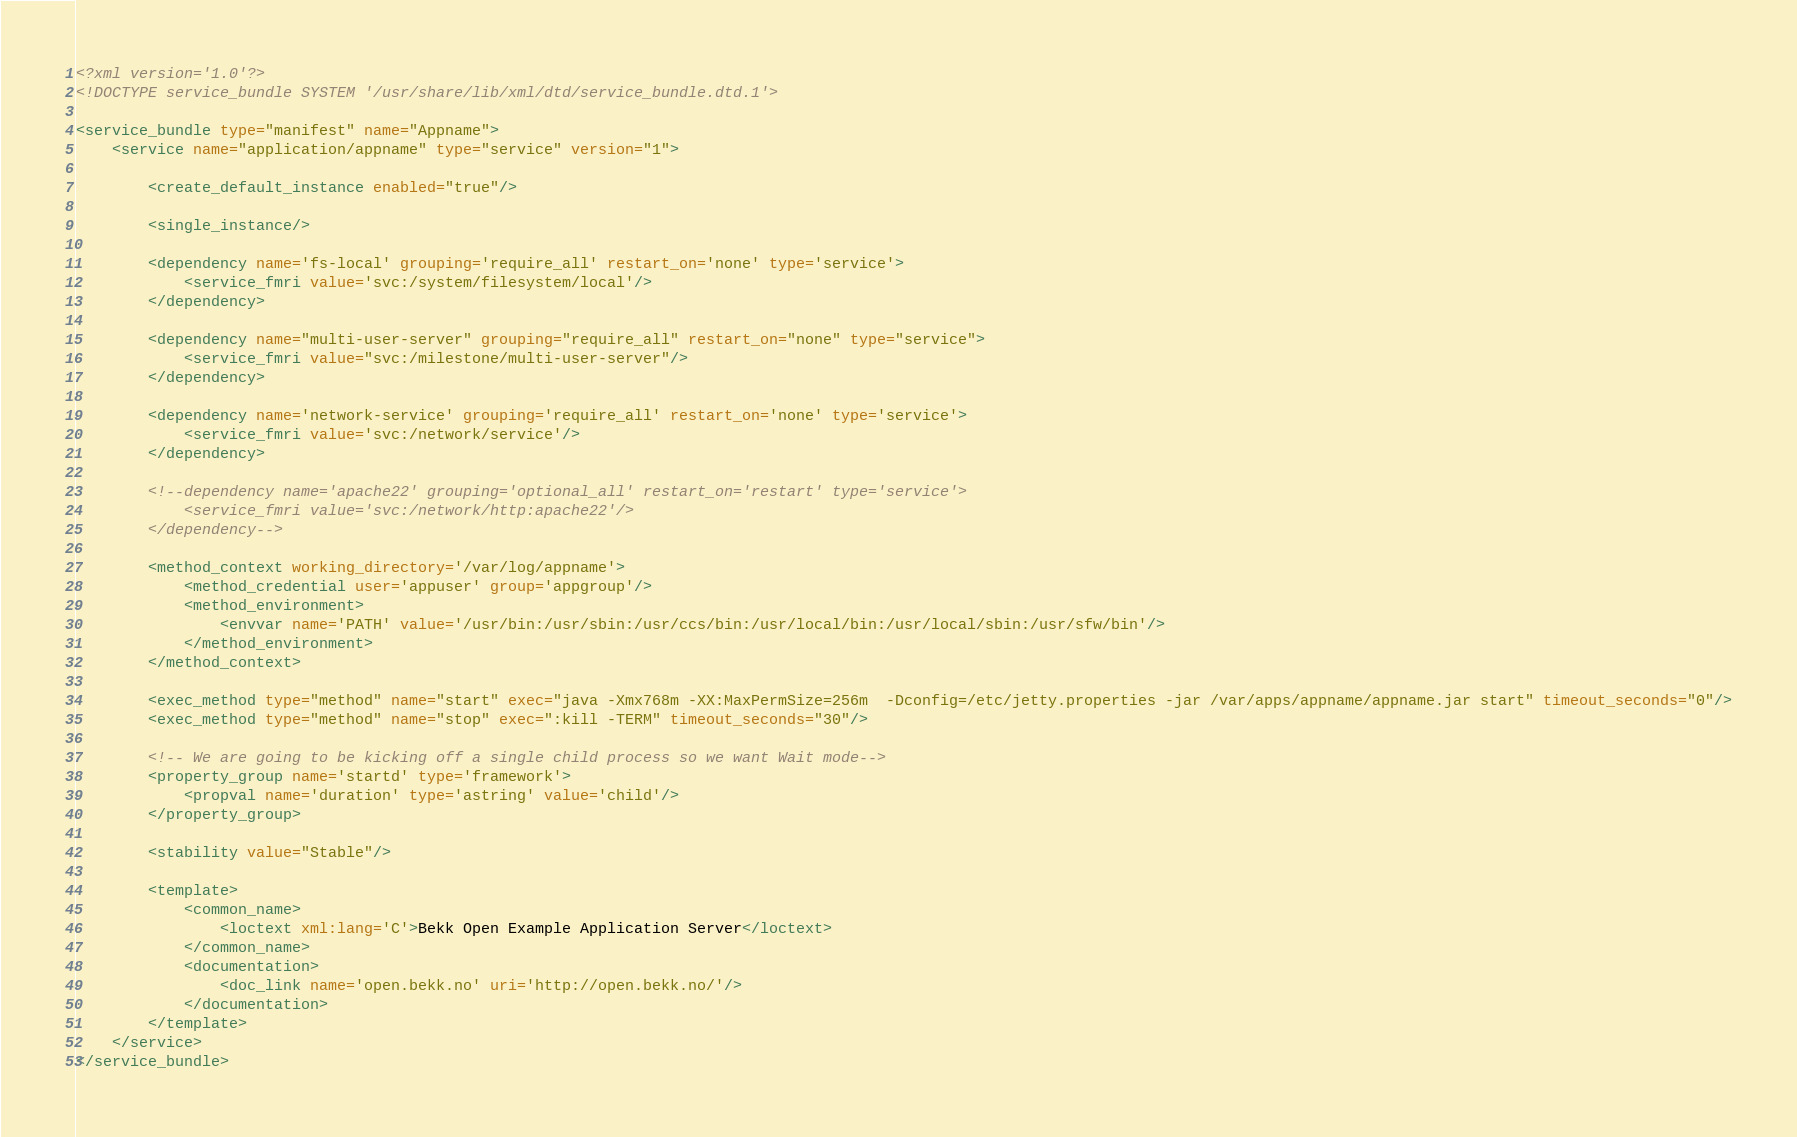Convert code to text. <code><loc_0><loc_0><loc_500><loc_500><_XML_><?xml version='1.0'?>
<!DOCTYPE service_bundle SYSTEM '/usr/share/lib/xml/dtd/service_bundle.dtd.1'>

<service_bundle type="manifest" name="Appname">
    <service name="application/appname" type="service" version="1">

        <create_default_instance enabled="true"/>

        <single_instance/>

        <dependency name='fs-local' grouping='require_all' restart_on='none' type='service'>
            <service_fmri value='svc:/system/filesystem/local'/>
        </dependency>

        <dependency name="multi-user-server" grouping="require_all" restart_on="none" type="service">
            <service_fmri value="svc:/milestone/multi-user-server"/>
        </dependency>

        <dependency name='network-service' grouping='require_all' restart_on='none' type='service'>
            <service_fmri value='svc:/network/service'/>
        </dependency>

        <!--dependency name='apache22' grouping='optional_all' restart_on='restart' type='service'>
            <service_fmri value='svc:/network/http:apache22'/>
        </dependency-->

        <method_context working_directory='/var/log/appname'>
            <method_credential user='appuser' group='appgroup'/>
            <method_environment>
                <envvar name='PATH' value='/usr/bin:/usr/sbin:/usr/ccs/bin:/usr/local/bin:/usr/local/sbin:/usr/sfw/bin'/>
            </method_environment>
        </method_context>

        <exec_method type="method" name="start" exec="java -Xmx768m -XX:MaxPermSize=256m  -Dconfig=/etc/jetty.properties -jar /var/apps/appname/appname.jar start" timeout_seconds="0"/>
        <exec_method type="method" name="stop" exec=":kill -TERM" timeout_seconds="30"/>

        <!-- We are going to be kicking off a single child process so we want Wait mode-->
        <property_group name='startd' type='framework'>
            <propval name='duration' type='astring' value='child'/>
        </property_group>

        <stability value="Stable"/>

        <template>
            <common_name>
                <loctext xml:lang='C'>Bekk Open Example Application Server</loctext>
            </common_name>
            <documentation>
                <doc_link name='open.bekk.no' uri='http://open.bekk.no/'/>
            </documentation>
        </template>
    </service>
</service_bundle>
</code> 